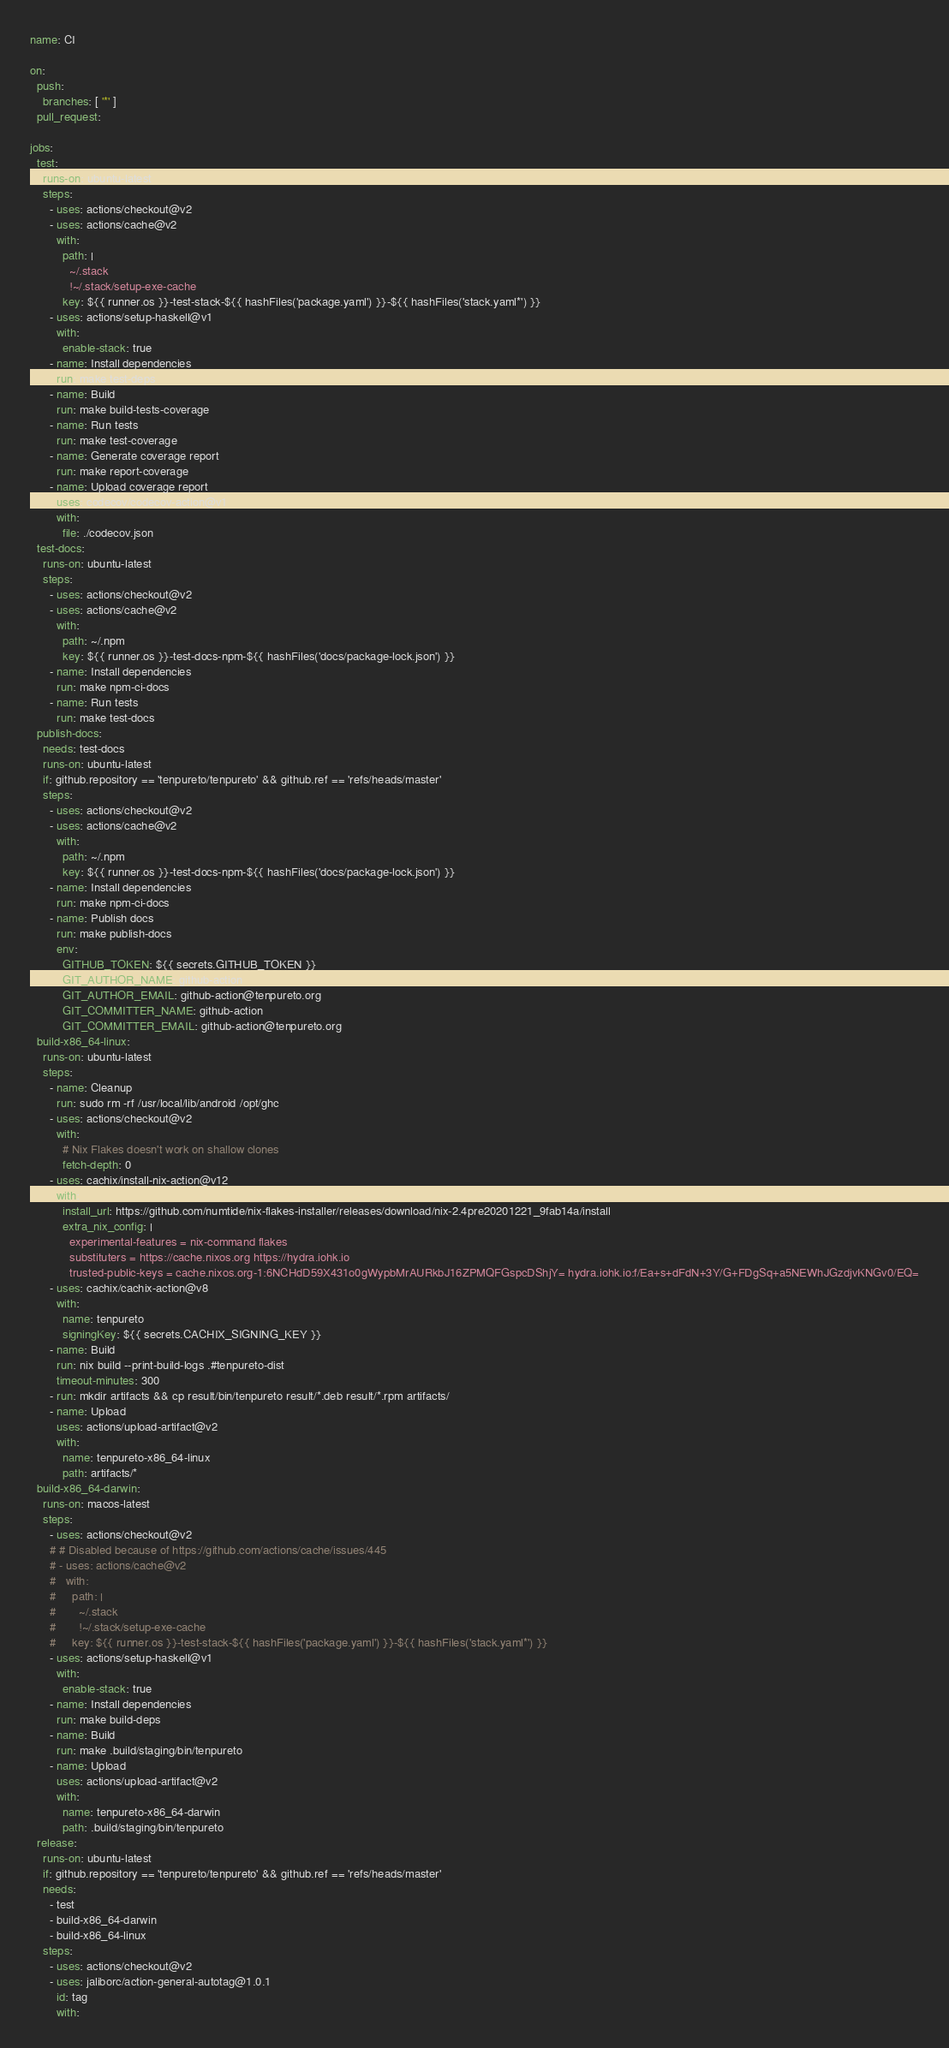Convert code to text. <code><loc_0><loc_0><loc_500><loc_500><_YAML_>name: CI

on:
  push:
    branches: [ '*' ]
  pull_request:

jobs:
  test:
    runs-on: ubuntu-latest
    steps:
      - uses: actions/checkout@v2
      - uses: actions/cache@v2
        with:
          path: |
            ~/.stack
            !~/.stack/setup-exe-cache
          key: ${{ runner.os }}-test-stack-${{ hashFiles('package.yaml') }}-${{ hashFiles('stack.yaml*') }}
      - uses: actions/setup-haskell@v1
        with:
          enable-stack: true
      - name: Install dependencies
        run: make test-deps
      - name: Build
        run: make build-tests-coverage
      - name: Run tests
        run: make test-coverage
      - name: Generate coverage report
        run: make report-coverage
      - name: Upload coverage report
        uses: codecov/codecov-action@v1
        with:
          file: ./codecov.json
  test-docs:
    runs-on: ubuntu-latest
    steps:
      - uses: actions/checkout@v2
      - uses: actions/cache@v2
        with:
          path: ~/.npm
          key: ${{ runner.os }}-test-docs-npm-${{ hashFiles('docs/package-lock.json') }}
      - name: Install dependencies
        run: make npm-ci-docs
      - name: Run tests
        run: make test-docs
  publish-docs:
    needs: test-docs
    runs-on: ubuntu-latest
    if: github.repository == 'tenpureto/tenpureto' && github.ref == 'refs/heads/master'
    steps:
      - uses: actions/checkout@v2
      - uses: actions/cache@v2
        with:
          path: ~/.npm
          key: ${{ runner.os }}-test-docs-npm-${{ hashFiles('docs/package-lock.json') }}
      - name: Install dependencies
        run: make npm-ci-docs
      - name: Publish docs
        run: make publish-docs
        env:
          GITHUB_TOKEN: ${{ secrets.GITHUB_TOKEN }}
          GIT_AUTHOR_NAME: github-action
          GIT_AUTHOR_EMAIL: github-action@tenpureto.org
          GIT_COMMITTER_NAME: github-action
          GIT_COMMITTER_EMAIL: github-action@tenpureto.org
  build-x86_64-linux:
    runs-on: ubuntu-latest
    steps:
      - name: Cleanup
        run: sudo rm -rf /usr/local/lib/android /opt/ghc
      - uses: actions/checkout@v2
        with:
          # Nix Flakes doesn't work on shallow clones
          fetch-depth: 0
      - uses: cachix/install-nix-action@v12
        with:
          install_url: https://github.com/numtide/nix-flakes-installer/releases/download/nix-2.4pre20201221_9fab14a/install
          extra_nix_config: |
            experimental-features = nix-command flakes
            substituters = https://cache.nixos.org https://hydra.iohk.io
            trusted-public-keys = cache.nixos.org-1:6NCHdD59X431o0gWypbMrAURkbJ16ZPMQFGspcDShjY= hydra.iohk.io:f/Ea+s+dFdN+3Y/G+FDgSq+a5NEWhJGzdjvKNGv0/EQ=
      - uses: cachix/cachix-action@v8
        with:
          name: tenpureto
          signingKey: ${{ secrets.CACHIX_SIGNING_KEY }}
      - name: Build
        run: nix build --print-build-logs .#tenpureto-dist
        timeout-minutes: 300
      - run: mkdir artifacts && cp result/bin/tenpureto result/*.deb result/*.rpm artifacts/
      - name: Upload
        uses: actions/upload-artifact@v2
        with:
          name: tenpureto-x86_64-linux
          path: artifacts/*
  build-x86_64-darwin:
    runs-on: macos-latest
    steps:
      - uses: actions/checkout@v2
      # # Disabled because of https://github.com/actions/cache/issues/445
      # - uses: actions/cache@v2
      #   with:
      #     path: |
      #       ~/.stack
      #       !~/.stack/setup-exe-cache
      #     key: ${{ runner.os }}-test-stack-${{ hashFiles('package.yaml') }}-${{ hashFiles('stack.yaml*') }}
      - uses: actions/setup-haskell@v1
        with:
          enable-stack: true
      - name: Install dependencies
        run: make build-deps
      - name: Build
        run: make .build/staging/bin/tenpureto
      - name: Upload
        uses: actions/upload-artifact@v2
        with:
          name: tenpureto-x86_64-darwin
          path: .build/staging/bin/tenpureto
  release:
    runs-on: ubuntu-latest
    if: github.repository == 'tenpureto/tenpureto' && github.ref == 'refs/heads/master'
    needs:
      - test
      - build-x86_64-darwin
      - build-x86_64-linux
    steps:
      - uses: actions/checkout@v2
      - uses: jaliborc/action-general-autotag@1.0.1
        id: tag
        with:</code> 